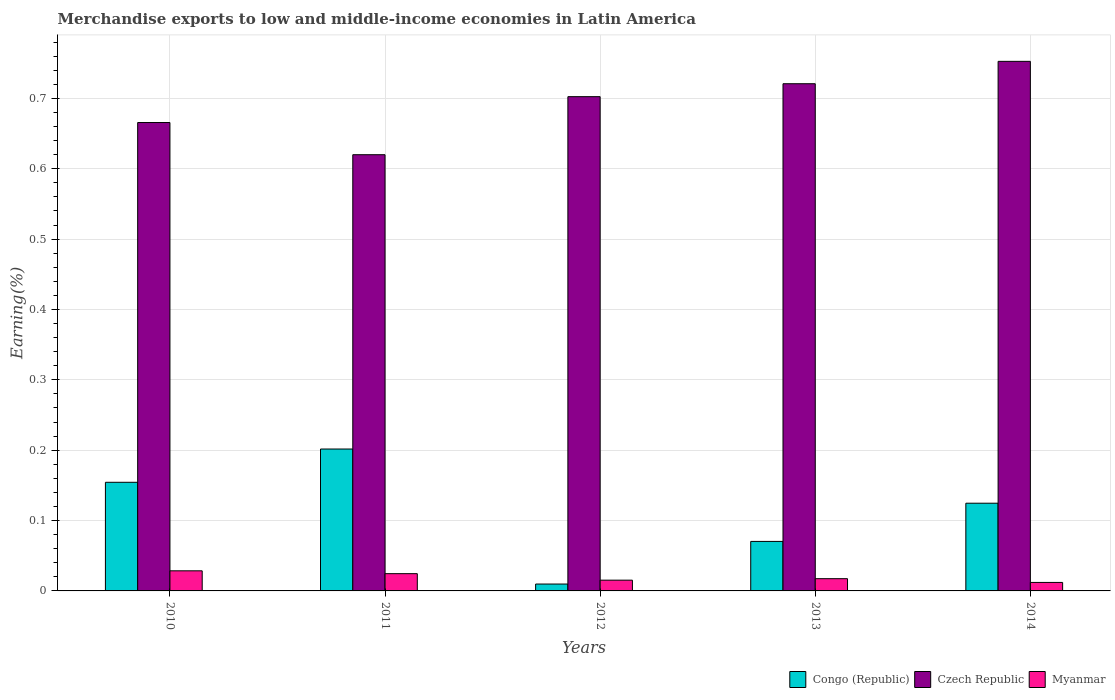How many different coloured bars are there?
Your answer should be very brief. 3. Are the number of bars per tick equal to the number of legend labels?
Keep it short and to the point. Yes. Are the number of bars on each tick of the X-axis equal?
Provide a succinct answer. Yes. What is the label of the 4th group of bars from the left?
Offer a very short reply. 2013. In how many cases, is the number of bars for a given year not equal to the number of legend labels?
Give a very brief answer. 0. What is the percentage of amount earned from merchandise exports in Czech Republic in 2013?
Make the answer very short. 0.72. Across all years, what is the maximum percentage of amount earned from merchandise exports in Myanmar?
Provide a succinct answer. 0.03. Across all years, what is the minimum percentage of amount earned from merchandise exports in Congo (Republic)?
Offer a terse response. 0.01. In which year was the percentage of amount earned from merchandise exports in Myanmar minimum?
Offer a very short reply. 2014. What is the total percentage of amount earned from merchandise exports in Myanmar in the graph?
Ensure brevity in your answer.  0.1. What is the difference between the percentage of amount earned from merchandise exports in Czech Republic in 2012 and that in 2013?
Ensure brevity in your answer.  -0.02. What is the difference between the percentage of amount earned from merchandise exports in Congo (Republic) in 2011 and the percentage of amount earned from merchandise exports in Czech Republic in 2014?
Offer a very short reply. -0.55. What is the average percentage of amount earned from merchandise exports in Czech Republic per year?
Offer a very short reply. 0.69. In the year 2014, what is the difference between the percentage of amount earned from merchandise exports in Myanmar and percentage of amount earned from merchandise exports in Congo (Republic)?
Give a very brief answer. -0.11. What is the ratio of the percentage of amount earned from merchandise exports in Congo (Republic) in 2013 to that in 2014?
Offer a terse response. 0.56. Is the difference between the percentage of amount earned from merchandise exports in Myanmar in 2013 and 2014 greater than the difference between the percentage of amount earned from merchandise exports in Congo (Republic) in 2013 and 2014?
Provide a succinct answer. Yes. What is the difference between the highest and the second highest percentage of amount earned from merchandise exports in Czech Republic?
Make the answer very short. 0.03. What is the difference between the highest and the lowest percentage of amount earned from merchandise exports in Czech Republic?
Make the answer very short. 0.13. In how many years, is the percentage of amount earned from merchandise exports in Congo (Republic) greater than the average percentage of amount earned from merchandise exports in Congo (Republic) taken over all years?
Keep it short and to the point. 3. What does the 2nd bar from the left in 2011 represents?
Offer a terse response. Czech Republic. What does the 1st bar from the right in 2011 represents?
Your answer should be very brief. Myanmar. Is it the case that in every year, the sum of the percentage of amount earned from merchandise exports in Czech Republic and percentage of amount earned from merchandise exports in Myanmar is greater than the percentage of amount earned from merchandise exports in Congo (Republic)?
Offer a terse response. Yes. How many bars are there?
Your answer should be very brief. 15. What is the difference between two consecutive major ticks on the Y-axis?
Make the answer very short. 0.1. Are the values on the major ticks of Y-axis written in scientific E-notation?
Offer a terse response. No. Does the graph contain grids?
Keep it short and to the point. Yes. Where does the legend appear in the graph?
Keep it short and to the point. Bottom right. How many legend labels are there?
Your response must be concise. 3. How are the legend labels stacked?
Keep it short and to the point. Horizontal. What is the title of the graph?
Ensure brevity in your answer.  Merchandise exports to low and middle-income economies in Latin America. Does "Nicaragua" appear as one of the legend labels in the graph?
Your answer should be very brief. No. What is the label or title of the X-axis?
Your answer should be compact. Years. What is the label or title of the Y-axis?
Provide a succinct answer. Earning(%). What is the Earning(%) of Congo (Republic) in 2010?
Provide a short and direct response. 0.15. What is the Earning(%) of Czech Republic in 2010?
Your response must be concise. 0.67. What is the Earning(%) in Myanmar in 2010?
Ensure brevity in your answer.  0.03. What is the Earning(%) of Congo (Republic) in 2011?
Keep it short and to the point. 0.2. What is the Earning(%) of Czech Republic in 2011?
Make the answer very short. 0.62. What is the Earning(%) of Myanmar in 2011?
Keep it short and to the point. 0.02. What is the Earning(%) in Congo (Republic) in 2012?
Offer a very short reply. 0.01. What is the Earning(%) in Czech Republic in 2012?
Your response must be concise. 0.7. What is the Earning(%) in Myanmar in 2012?
Offer a terse response. 0.02. What is the Earning(%) in Congo (Republic) in 2013?
Provide a succinct answer. 0.07. What is the Earning(%) in Czech Republic in 2013?
Your answer should be very brief. 0.72. What is the Earning(%) of Myanmar in 2013?
Give a very brief answer. 0.02. What is the Earning(%) of Congo (Republic) in 2014?
Provide a short and direct response. 0.12. What is the Earning(%) in Czech Republic in 2014?
Provide a short and direct response. 0.75. What is the Earning(%) in Myanmar in 2014?
Offer a very short reply. 0.01. Across all years, what is the maximum Earning(%) of Congo (Republic)?
Offer a terse response. 0.2. Across all years, what is the maximum Earning(%) in Czech Republic?
Keep it short and to the point. 0.75. Across all years, what is the maximum Earning(%) in Myanmar?
Offer a very short reply. 0.03. Across all years, what is the minimum Earning(%) of Congo (Republic)?
Your answer should be compact. 0.01. Across all years, what is the minimum Earning(%) of Czech Republic?
Your response must be concise. 0.62. Across all years, what is the minimum Earning(%) of Myanmar?
Offer a terse response. 0.01. What is the total Earning(%) of Congo (Republic) in the graph?
Offer a terse response. 0.56. What is the total Earning(%) of Czech Republic in the graph?
Give a very brief answer. 3.46. What is the total Earning(%) of Myanmar in the graph?
Provide a short and direct response. 0.1. What is the difference between the Earning(%) of Congo (Republic) in 2010 and that in 2011?
Offer a very short reply. -0.05. What is the difference between the Earning(%) in Czech Republic in 2010 and that in 2011?
Keep it short and to the point. 0.05. What is the difference between the Earning(%) in Myanmar in 2010 and that in 2011?
Give a very brief answer. 0. What is the difference between the Earning(%) in Congo (Republic) in 2010 and that in 2012?
Your answer should be compact. 0.14. What is the difference between the Earning(%) in Czech Republic in 2010 and that in 2012?
Provide a succinct answer. -0.04. What is the difference between the Earning(%) in Myanmar in 2010 and that in 2012?
Offer a terse response. 0.01. What is the difference between the Earning(%) in Congo (Republic) in 2010 and that in 2013?
Make the answer very short. 0.08. What is the difference between the Earning(%) of Czech Republic in 2010 and that in 2013?
Offer a terse response. -0.06. What is the difference between the Earning(%) of Myanmar in 2010 and that in 2013?
Your response must be concise. 0.01. What is the difference between the Earning(%) in Congo (Republic) in 2010 and that in 2014?
Give a very brief answer. 0.03. What is the difference between the Earning(%) in Czech Republic in 2010 and that in 2014?
Your response must be concise. -0.09. What is the difference between the Earning(%) of Myanmar in 2010 and that in 2014?
Offer a terse response. 0.02. What is the difference between the Earning(%) of Congo (Republic) in 2011 and that in 2012?
Offer a very short reply. 0.19. What is the difference between the Earning(%) in Czech Republic in 2011 and that in 2012?
Your response must be concise. -0.08. What is the difference between the Earning(%) of Myanmar in 2011 and that in 2012?
Give a very brief answer. 0.01. What is the difference between the Earning(%) of Congo (Republic) in 2011 and that in 2013?
Your response must be concise. 0.13. What is the difference between the Earning(%) of Czech Republic in 2011 and that in 2013?
Offer a very short reply. -0.1. What is the difference between the Earning(%) in Myanmar in 2011 and that in 2013?
Provide a short and direct response. 0.01. What is the difference between the Earning(%) of Congo (Republic) in 2011 and that in 2014?
Make the answer very short. 0.08. What is the difference between the Earning(%) in Czech Republic in 2011 and that in 2014?
Your response must be concise. -0.13. What is the difference between the Earning(%) in Myanmar in 2011 and that in 2014?
Offer a very short reply. 0.01. What is the difference between the Earning(%) in Congo (Republic) in 2012 and that in 2013?
Your response must be concise. -0.06. What is the difference between the Earning(%) of Czech Republic in 2012 and that in 2013?
Your answer should be compact. -0.02. What is the difference between the Earning(%) in Myanmar in 2012 and that in 2013?
Give a very brief answer. -0. What is the difference between the Earning(%) of Congo (Republic) in 2012 and that in 2014?
Your response must be concise. -0.11. What is the difference between the Earning(%) of Czech Republic in 2012 and that in 2014?
Make the answer very short. -0.05. What is the difference between the Earning(%) in Myanmar in 2012 and that in 2014?
Your response must be concise. 0. What is the difference between the Earning(%) in Congo (Republic) in 2013 and that in 2014?
Your answer should be compact. -0.05. What is the difference between the Earning(%) of Czech Republic in 2013 and that in 2014?
Ensure brevity in your answer.  -0.03. What is the difference between the Earning(%) of Myanmar in 2013 and that in 2014?
Your answer should be very brief. 0.01. What is the difference between the Earning(%) of Congo (Republic) in 2010 and the Earning(%) of Czech Republic in 2011?
Give a very brief answer. -0.47. What is the difference between the Earning(%) in Congo (Republic) in 2010 and the Earning(%) in Myanmar in 2011?
Offer a very short reply. 0.13. What is the difference between the Earning(%) in Czech Republic in 2010 and the Earning(%) in Myanmar in 2011?
Provide a succinct answer. 0.64. What is the difference between the Earning(%) of Congo (Republic) in 2010 and the Earning(%) of Czech Republic in 2012?
Make the answer very short. -0.55. What is the difference between the Earning(%) of Congo (Republic) in 2010 and the Earning(%) of Myanmar in 2012?
Provide a succinct answer. 0.14. What is the difference between the Earning(%) of Czech Republic in 2010 and the Earning(%) of Myanmar in 2012?
Make the answer very short. 0.65. What is the difference between the Earning(%) of Congo (Republic) in 2010 and the Earning(%) of Czech Republic in 2013?
Provide a succinct answer. -0.57. What is the difference between the Earning(%) of Congo (Republic) in 2010 and the Earning(%) of Myanmar in 2013?
Offer a terse response. 0.14. What is the difference between the Earning(%) in Czech Republic in 2010 and the Earning(%) in Myanmar in 2013?
Make the answer very short. 0.65. What is the difference between the Earning(%) in Congo (Republic) in 2010 and the Earning(%) in Czech Republic in 2014?
Your response must be concise. -0.6. What is the difference between the Earning(%) of Congo (Republic) in 2010 and the Earning(%) of Myanmar in 2014?
Provide a succinct answer. 0.14. What is the difference between the Earning(%) of Czech Republic in 2010 and the Earning(%) of Myanmar in 2014?
Your answer should be compact. 0.65. What is the difference between the Earning(%) of Congo (Republic) in 2011 and the Earning(%) of Czech Republic in 2012?
Your answer should be very brief. -0.5. What is the difference between the Earning(%) in Congo (Republic) in 2011 and the Earning(%) in Myanmar in 2012?
Provide a succinct answer. 0.19. What is the difference between the Earning(%) of Czech Republic in 2011 and the Earning(%) of Myanmar in 2012?
Your answer should be compact. 0.6. What is the difference between the Earning(%) in Congo (Republic) in 2011 and the Earning(%) in Czech Republic in 2013?
Give a very brief answer. -0.52. What is the difference between the Earning(%) of Congo (Republic) in 2011 and the Earning(%) of Myanmar in 2013?
Provide a short and direct response. 0.18. What is the difference between the Earning(%) of Czech Republic in 2011 and the Earning(%) of Myanmar in 2013?
Give a very brief answer. 0.6. What is the difference between the Earning(%) in Congo (Republic) in 2011 and the Earning(%) in Czech Republic in 2014?
Provide a succinct answer. -0.55. What is the difference between the Earning(%) of Congo (Republic) in 2011 and the Earning(%) of Myanmar in 2014?
Give a very brief answer. 0.19. What is the difference between the Earning(%) in Czech Republic in 2011 and the Earning(%) in Myanmar in 2014?
Give a very brief answer. 0.61. What is the difference between the Earning(%) of Congo (Republic) in 2012 and the Earning(%) of Czech Republic in 2013?
Your answer should be very brief. -0.71. What is the difference between the Earning(%) in Congo (Republic) in 2012 and the Earning(%) in Myanmar in 2013?
Provide a short and direct response. -0.01. What is the difference between the Earning(%) in Czech Republic in 2012 and the Earning(%) in Myanmar in 2013?
Provide a short and direct response. 0.69. What is the difference between the Earning(%) of Congo (Republic) in 2012 and the Earning(%) of Czech Republic in 2014?
Make the answer very short. -0.74. What is the difference between the Earning(%) in Congo (Republic) in 2012 and the Earning(%) in Myanmar in 2014?
Your response must be concise. -0. What is the difference between the Earning(%) in Czech Republic in 2012 and the Earning(%) in Myanmar in 2014?
Your response must be concise. 0.69. What is the difference between the Earning(%) in Congo (Republic) in 2013 and the Earning(%) in Czech Republic in 2014?
Make the answer very short. -0.68. What is the difference between the Earning(%) of Congo (Republic) in 2013 and the Earning(%) of Myanmar in 2014?
Provide a short and direct response. 0.06. What is the difference between the Earning(%) of Czech Republic in 2013 and the Earning(%) of Myanmar in 2014?
Make the answer very short. 0.71. What is the average Earning(%) in Congo (Republic) per year?
Give a very brief answer. 0.11. What is the average Earning(%) of Czech Republic per year?
Your answer should be compact. 0.69. What is the average Earning(%) in Myanmar per year?
Your response must be concise. 0.02. In the year 2010, what is the difference between the Earning(%) in Congo (Republic) and Earning(%) in Czech Republic?
Give a very brief answer. -0.51. In the year 2010, what is the difference between the Earning(%) in Congo (Republic) and Earning(%) in Myanmar?
Offer a terse response. 0.13. In the year 2010, what is the difference between the Earning(%) in Czech Republic and Earning(%) in Myanmar?
Ensure brevity in your answer.  0.64. In the year 2011, what is the difference between the Earning(%) in Congo (Republic) and Earning(%) in Czech Republic?
Make the answer very short. -0.42. In the year 2011, what is the difference between the Earning(%) of Congo (Republic) and Earning(%) of Myanmar?
Offer a terse response. 0.18. In the year 2011, what is the difference between the Earning(%) in Czech Republic and Earning(%) in Myanmar?
Your answer should be compact. 0.6. In the year 2012, what is the difference between the Earning(%) in Congo (Republic) and Earning(%) in Czech Republic?
Your answer should be compact. -0.69. In the year 2012, what is the difference between the Earning(%) in Congo (Republic) and Earning(%) in Myanmar?
Make the answer very short. -0.01. In the year 2012, what is the difference between the Earning(%) in Czech Republic and Earning(%) in Myanmar?
Offer a terse response. 0.69. In the year 2013, what is the difference between the Earning(%) in Congo (Republic) and Earning(%) in Czech Republic?
Offer a very short reply. -0.65. In the year 2013, what is the difference between the Earning(%) in Congo (Republic) and Earning(%) in Myanmar?
Your response must be concise. 0.05. In the year 2013, what is the difference between the Earning(%) of Czech Republic and Earning(%) of Myanmar?
Offer a very short reply. 0.7. In the year 2014, what is the difference between the Earning(%) of Congo (Republic) and Earning(%) of Czech Republic?
Your response must be concise. -0.63. In the year 2014, what is the difference between the Earning(%) in Congo (Republic) and Earning(%) in Myanmar?
Give a very brief answer. 0.11. In the year 2014, what is the difference between the Earning(%) in Czech Republic and Earning(%) in Myanmar?
Make the answer very short. 0.74. What is the ratio of the Earning(%) of Congo (Republic) in 2010 to that in 2011?
Your answer should be compact. 0.77. What is the ratio of the Earning(%) in Czech Republic in 2010 to that in 2011?
Keep it short and to the point. 1.07. What is the ratio of the Earning(%) of Myanmar in 2010 to that in 2011?
Offer a terse response. 1.16. What is the ratio of the Earning(%) of Congo (Republic) in 2010 to that in 2012?
Offer a very short reply. 15.78. What is the ratio of the Earning(%) in Czech Republic in 2010 to that in 2012?
Give a very brief answer. 0.95. What is the ratio of the Earning(%) in Myanmar in 2010 to that in 2012?
Provide a succinct answer. 1.87. What is the ratio of the Earning(%) of Congo (Republic) in 2010 to that in 2013?
Provide a short and direct response. 2.19. What is the ratio of the Earning(%) in Czech Republic in 2010 to that in 2013?
Ensure brevity in your answer.  0.92. What is the ratio of the Earning(%) of Myanmar in 2010 to that in 2013?
Keep it short and to the point. 1.64. What is the ratio of the Earning(%) in Congo (Republic) in 2010 to that in 2014?
Provide a short and direct response. 1.24. What is the ratio of the Earning(%) of Czech Republic in 2010 to that in 2014?
Provide a succinct answer. 0.88. What is the ratio of the Earning(%) in Myanmar in 2010 to that in 2014?
Ensure brevity in your answer.  2.37. What is the ratio of the Earning(%) in Congo (Republic) in 2011 to that in 2012?
Ensure brevity in your answer.  20.61. What is the ratio of the Earning(%) in Czech Republic in 2011 to that in 2012?
Ensure brevity in your answer.  0.88. What is the ratio of the Earning(%) of Myanmar in 2011 to that in 2012?
Your answer should be compact. 1.6. What is the ratio of the Earning(%) of Congo (Republic) in 2011 to that in 2013?
Keep it short and to the point. 2.87. What is the ratio of the Earning(%) in Czech Republic in 2011 to that in 2013?
Offer a very short reply. 0.86. What is the ratio of the Earning(%) of Myanmar in 2011 to that in 2013?
Provide a succinct answer. 1.41. What is the ratio of the Earning(%) in Congo (Republic) in 2011 to that in 2014?
Your response must be concise. 1.62. What is the ratio of the Earning(%) in Czech Republic in 2011 to that in 2014?
Keep it short and to the point. 0.82. What is the ratio of the Earning(%) of Myanmar in 2011 to that in 2014?
Your answer should be compact. 2.03. What is the ratio of the Earning(%) of Congo (Republic) in 2012 to that in 2013?
Offer a very short reply. 0.14. What is the ratio of the Earning(%) in Czech Republic in 2012 to that in 2013?
Your answer should be compact. 0.97. What is the ratio of the Earning(%) of Myanmar in 2012 to that in 2013?
Keep it short and to the point. 0.88. What is the ratio of the Earning(%) of Congo (Republic) in 2012 to that in 2014?
Offer a very short reply. 0.08. What is the ratio of the Earning(%) in Myanmar in 2012 to that in 2014?
Make the answer very short. 1.27. What is the ratio of the Earning(%) of Congo (Republic) in 2013 to that in 2014?
Provide a succinct answer. 0.56. What is the ratio of the Earning(%) in Czech Republic in 2013 to that in 2014?
Your answer should be very brief. 0.96. What is the ratio of the Earning(%) of Myanmar in 2013 to that in 2014?
Your answer should be compact. 1.44. What is the difference between the highest and the second highest Earning(%) of Congo (Republic)?
Make the answer very short. 0.05. What is the difference between the highest and the second highest Earning(%) of Czech Republic?
Offer a very short reply. 0.03. What is the difference between the highest and the second highest Earning(%) of Myanmar?
Give a very brief answer. 0. What is the difference between the highest and the lowest Earning(%) in Congo (Republic)?
Your answer should be compact. 0.19. What is the difference between the highest and the lowest Earning(%) in Czech Republic?
Your answer should be very brief. 0.13. What is the difference between the highest and the lowest Earning(%) in Myanmar?
Your answer should be very brief. 0.02. 